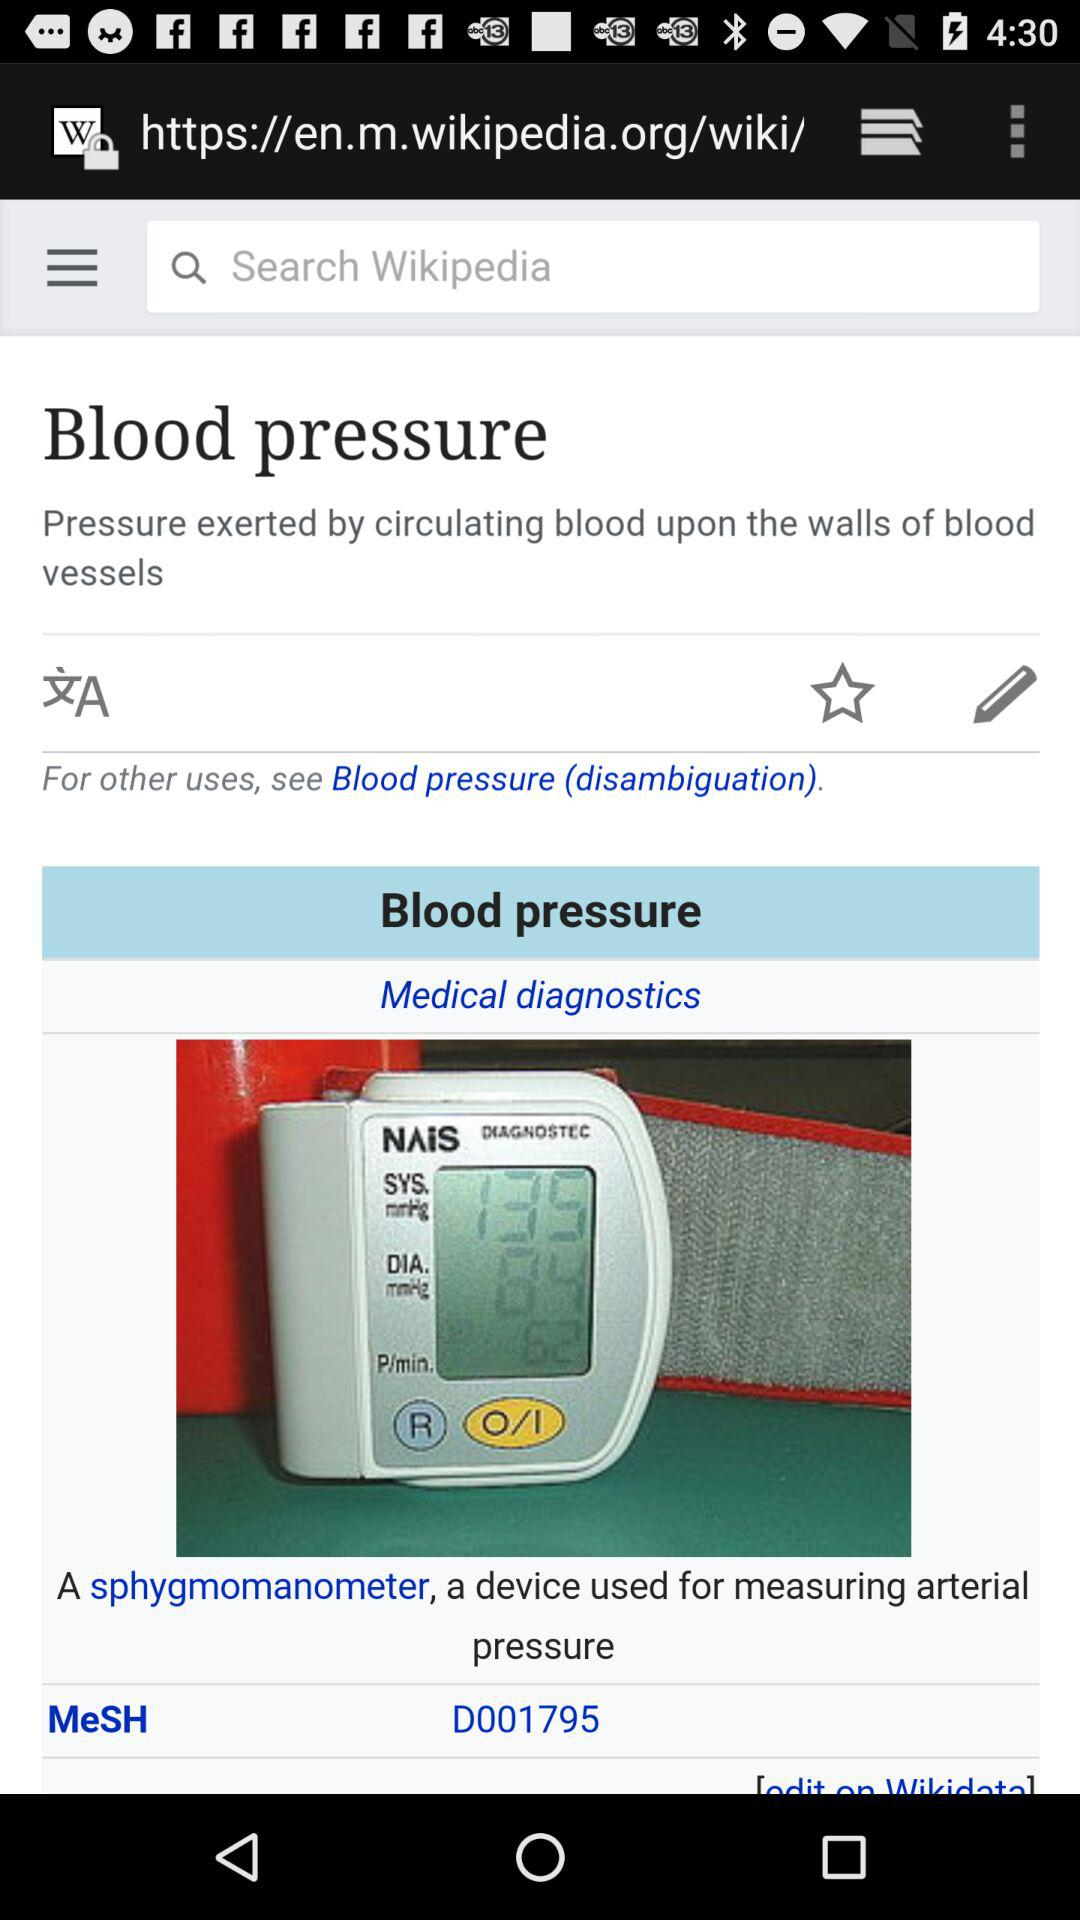What is the systolic pressure? The systolic pressure is 135. 